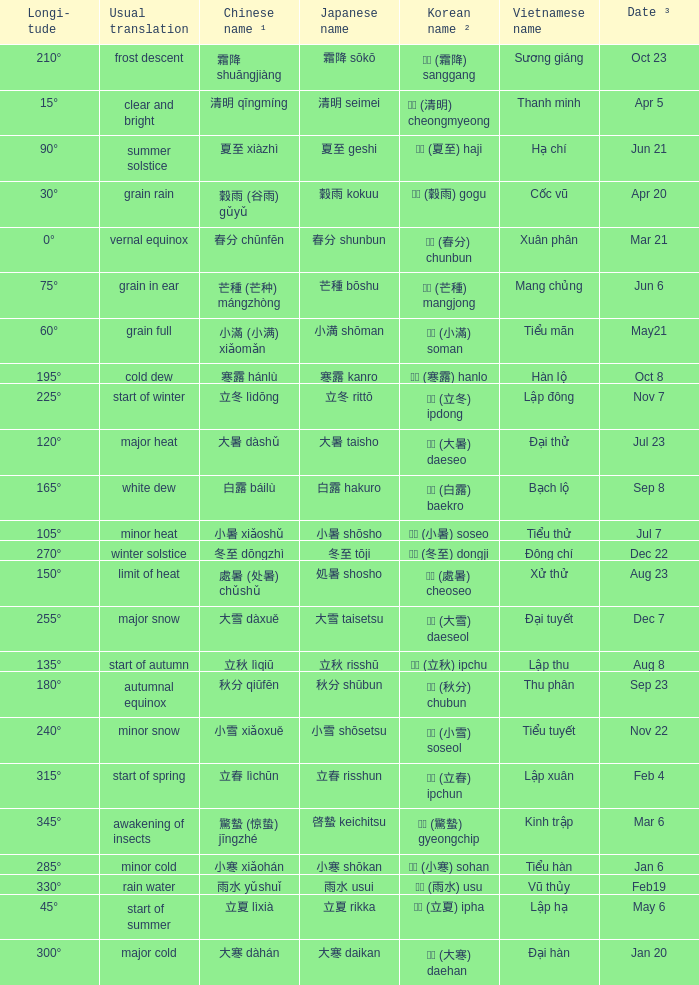Could you help me parse every detail presented in this table? {'header': ['Longi- tude', 'Usual translation', 'Chinese name ¹', 'Japanese name', 'Korean name ²', 'Vietnamese name', 'Date ³'], 'rows': [['210°', 'frost descent', '霜降 shuāngjiàng', '霜降 sōkō', '상강 (霜降) sanggang', 'Sương giáng', 'Oct 23'], ['15°', 'clear and bright', '清明 qīngmíng', '清明 seimei', '청명 (清明) cheongmyeong', 'Thanh minh', 'Apr 5'], ['90°', 'summer solstice', '夏至 xiàzhì', '夏至 geshi', '하지 (夏至) haji', 'Hạ chí', 'Jun 21'], ['30°', 'grain rain', '穀雨 (谷雨) gǔyǔ', '穀雨 kokuu', '곡우 (穀雨) gogu', 'Cốc vũ', 'Apr 20'], ['0°', 'vernal equinox', '春分 chūnfēn', '春分 shunbun', '춘분 (春分) chunbun', 'Xuân phân', 'Mar 21'], ['75°', 'grain in ear', '芒種 (芒种) mángzhòng', '芒種 bōshu', '망종 (芒種) mangjong', 'Mang chủng', 'Jun 6'], ['60°', 'grain full', '小滿 (小满) xiǎomǎn', '小満 shōman', '소만 (小滿) soman', 'Tiểu mãn', 'May21'], ['195°', 'cold dew', '寒露 hánlù', '寒露 kanro', '한로 (寒露) hanlo', 'Hàn lộ', 'Oct 8'], ['225°', 'start of winter', '立冬 lìdōng', '立冬 rittō', '입동 (立冬) ipdong', 'Lập đông', 'Nov 7'], ['120°', 'major heat', '大暑 dàshǔ', '大暑 taisho', '대서 (大暑) daeseo', 'Đại thử', 'Jul 23'], ['165°', 'white dew', '白露 báilù', '白露 hakuro', '백로 (白露) baekro', 'Bạch lộ', 'Sep 8'], ['105°', 'minor heat', '小暑 xiǎoshǔ', '小暑 shōsho', '소서 (小暑) soseo', 'Tiểu thử', 'Jul 7'], ['270°', 'winter solstice', '冬至 dōngzhì', '冬至 tōji', '동지 (冬至) dongji', 'Đông chí', 'Dec 22'], ['150°', 'limit of heat', '處暑 (处暑) chǔshǔ', '処暑 shosho', '처서 (處暑) cheoseo', 'Xử thử', 'Aug 23'], ['255°', 'major snow', '大雪 dàxuě', '大雪 taisetsu', '대설 (大雪) daeseol', 'Đại tuyết', 'Dec 7'], ['135°', 'start of autumn', '立秋 lìqiū', '立秋 risshū', '입추 (立秋) ipchu', 'Lập thu', 'Aug 8'], ['180°', 'autumnal equinox', '秋分 qiūfēn', '秋分 shūbun', '추분 (秋分) chubun', 'Thu phân', 'Sep 23'], ['240°', 'minor snow', '小雪 xiǎoxuě', '小雪 shōsetsu', '소설 (小雪) soseol', 'Tiểu tuyết', 'Nov 22'], ['315°', 'start of spring', '立春 lìchūn', '立春 risshun', '입춘 (立春) ipchun', 'Lập xuân', 'Feb 4'], ['345°', 'awakening of insects', '驚蟄 (惊蛰) jīngzhé', '啓蟄 keichitsu', '경칩 (驚蟄) gyeongchip', 'Kinh trập', 'Mar 6'], ['285°', 'minor cold', '小寒 xiǎohán', '小寒 shōkan', '소한 (小寒) sohan', 'Tiểu hàn', 'Jan 6'], ['330°', 'rain water', '雨水 yǔshuǐ', '雨水 usui', '우수 (雨水) usu', 'Vũ thủy', 'Feb19'], ['45°', 'start of summer', '立夏 lìxià', '立夏 rikka', '입하 (立夏) ipha', 'Lập hạ', 'May 6'], ['300°', 'major cold', '大寒 dàhán', '大寒 daikan', '대한 (大寒) daehan', 'Đại hàn', 'Jan 20']]} WHICH Vietnamese name has a Chinese name ¹ of 芒種 (芒种) mángzhòng? Mang chủng. 